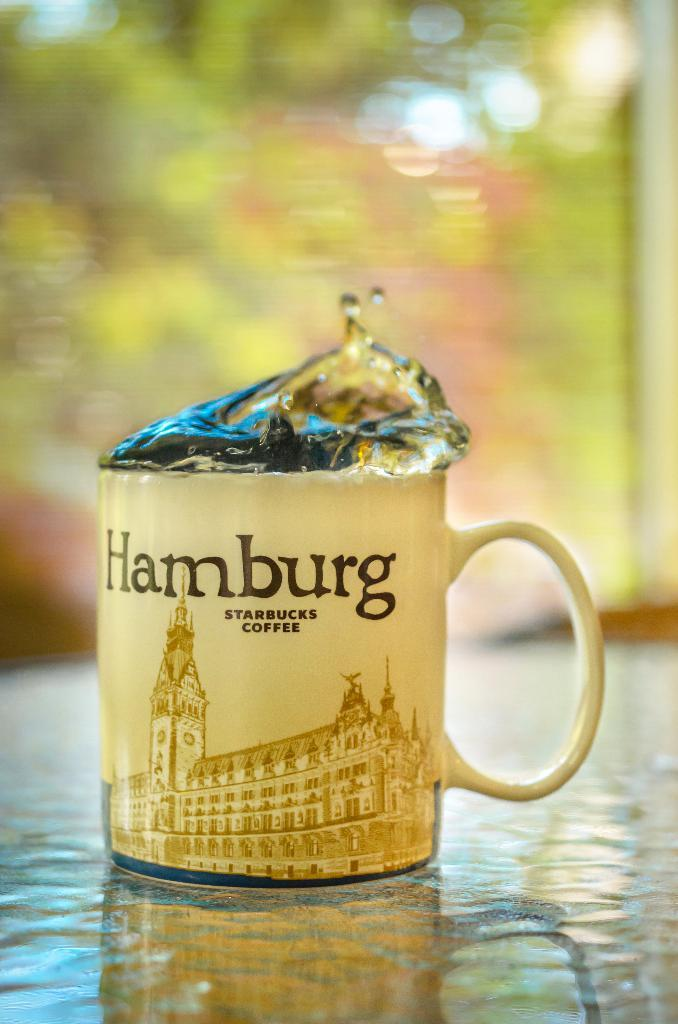Provide a one-sentence caption for the provided image. A mug with "Hamburg" written on it and some liquid coming out. 